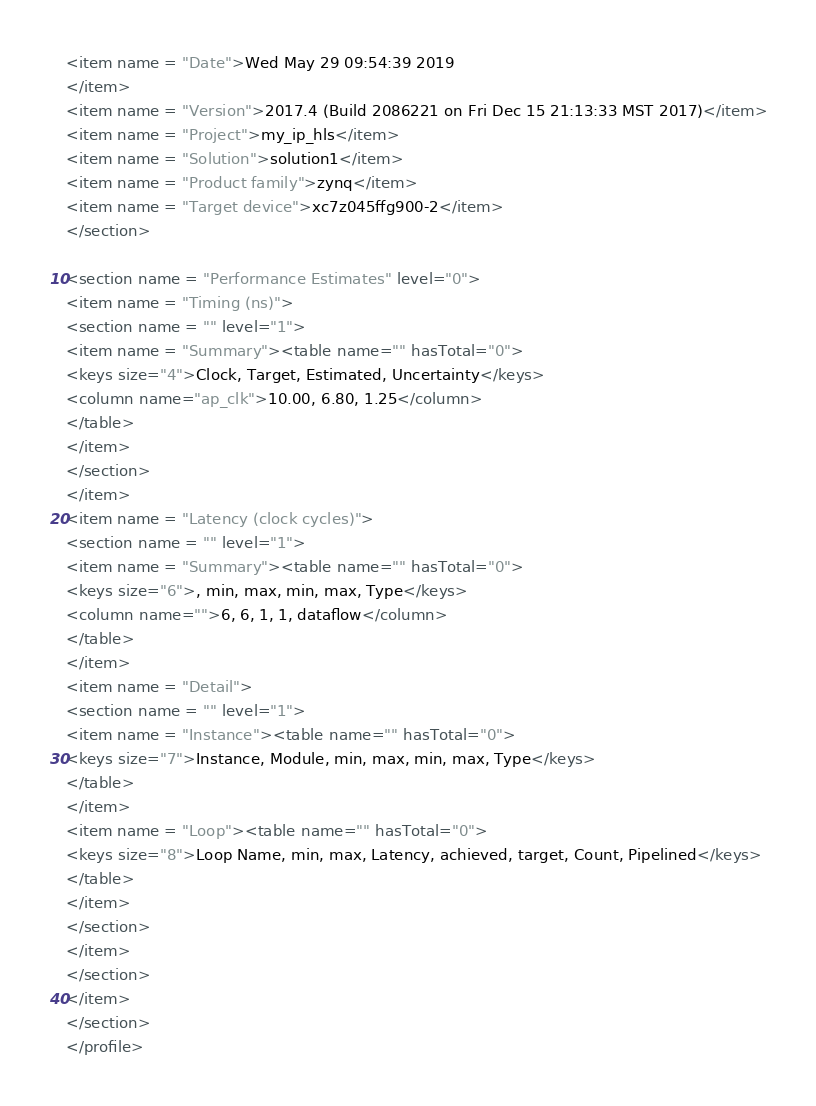<code> <loc_0><loc_0><loc_500><loc_500><_XML_><item name = "Date">Wed May 29 09:54:39 2019
</item>
<item name = "Version">2017.4 (Build 2086221 on Fri Dec 15 21:13:33 MST 2017)</item>
<item name = "Project">my_ip_hls</item>
<item name = "Solution">solution1</item>
<item name = "Product family">zynq</item>
<item name = "Target device">xc7z045ffg900-2</item>
</section>

<section name = "Performance Estimates" level="0">
<item name = "Timing (ns)">
<section name = "" level="1">
<item name = "Summary"><table name="" hasTotal="0">
<keys size="4">Clock, Target, Estimated, Uncertainty</keys>
<column name="ap_clk">10.00, 6.80, 1.25</column>
</table>
</item>
</section>
</item>
<item name = "Latency (clock cycles)">
<section name = "" level="1">
<item name = "Summary"><table name="" hasTotal="0">
<keys size="6">, min, max, min, max, Type</keys>
<column name="">6, 6, 1, 1, dataflow</column>
</table>
</item>
<item name = "Detail">
<section name = "" level="1">
<item name = "Instance"><table name="" hasTotal="0">
<keys size="7">Instance, Module, min, max, min, max, Type</keys>
</table>
</item>
<item name = "Loop"><table name="" hasTotal="0">
<keys size="8">Loop Name, min, max, Latency, achieved, target, Count, Pipelined</keys>
</table>
</item>
</section>
</item>
</section>
</item>
</section>
</profile>
</code> 